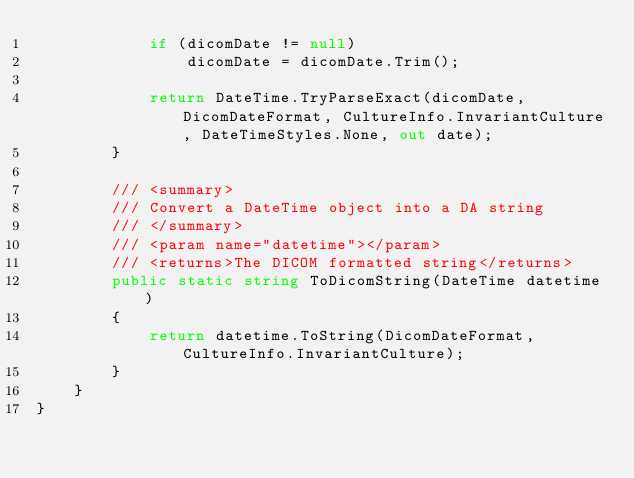Convert code to text. <code><loc_0><loc_0><loc_500><loc_500><_C#_>			if (dicomDate != null)
				dicomDate = dicomDate.Trim();

			return DateTime.TryParseExact(dicomDate, DicomDateFormat, CultureInfo.InvariantCulture, DateTimeStyles.None, out date);
		}

		/// <summary>
		/// Convert a DateTime object into a DA string
		/// </summary>
		/// <param name="datetime"></param>
		/// <returns>The DICOM formatted string</returns>
		public static string ToDicomString(DateTime datetime)
		{
			return datetime.ToString(DicomDateFormat, CultureInfo.InvariantCulture);
		}
	}
}</code> 